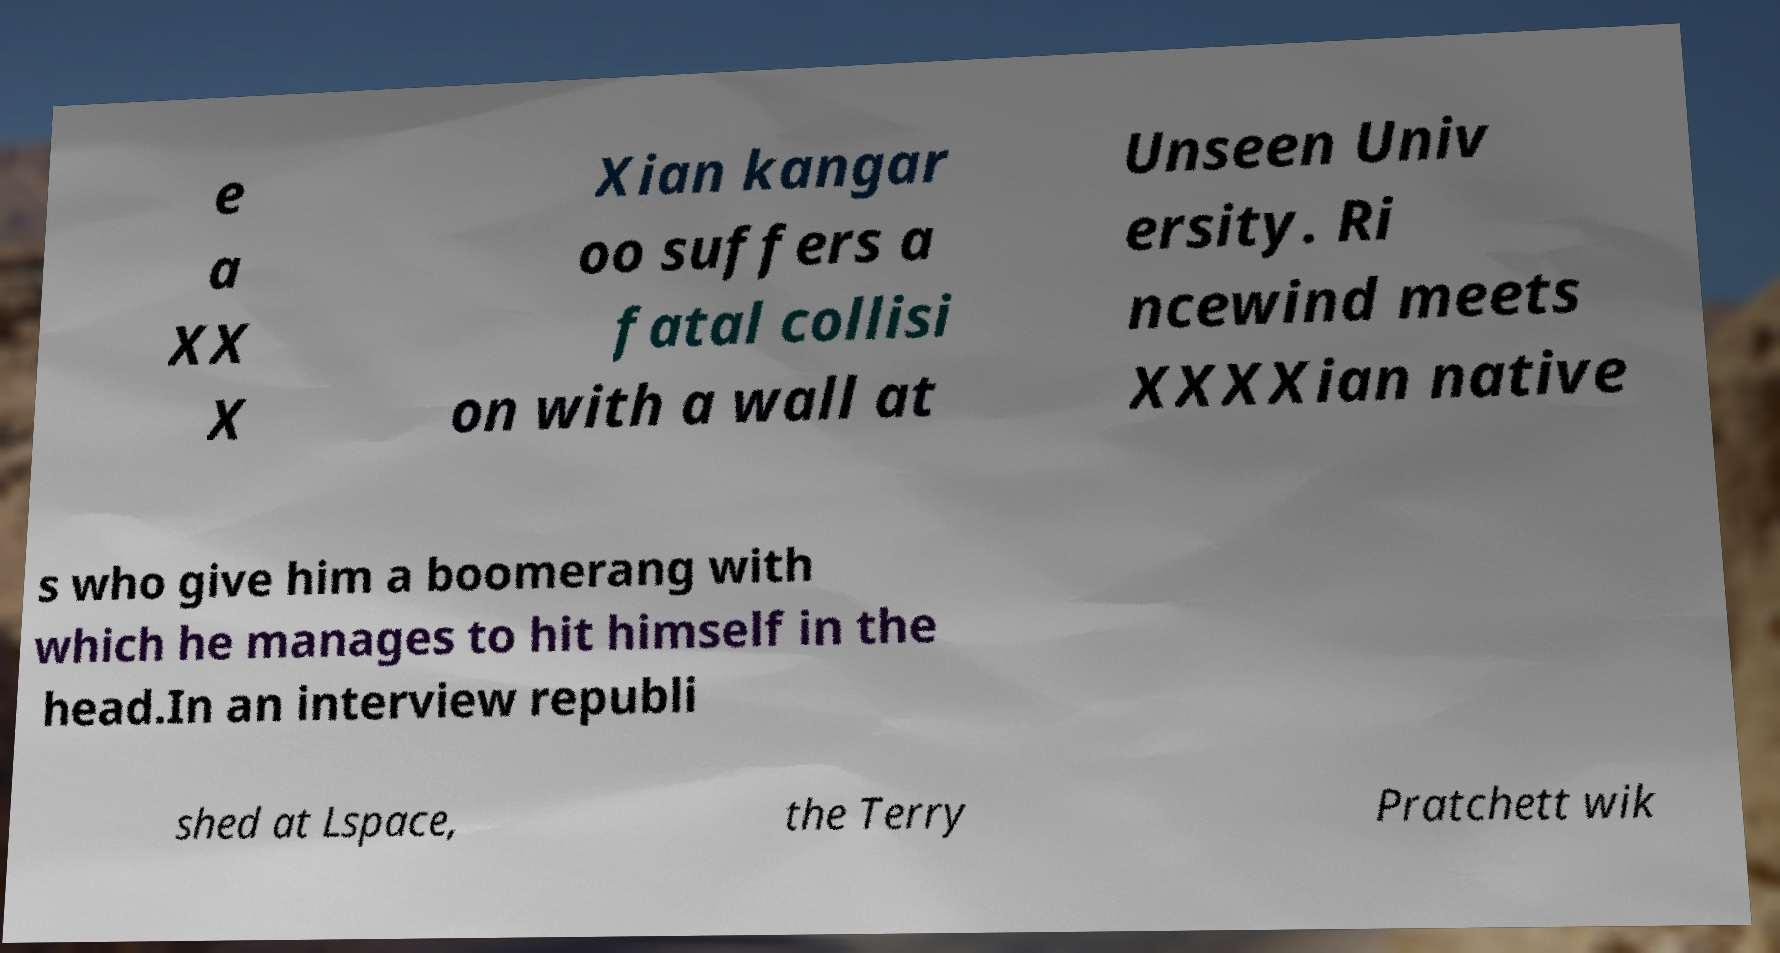Can you read and provide the text displayed in the image?This photo seems to have some interesting text. Can you extract and type it out for me? e a XX X Xian kangar oo suffers a fatal collisi on with a wall at Unseen Univ ersity. Ri ncewind meets XXXXian native s who give him a boomerang with which he manages to hit himself in the head.In an interview republi shed at Lspace, the Terry Pratchett wik 